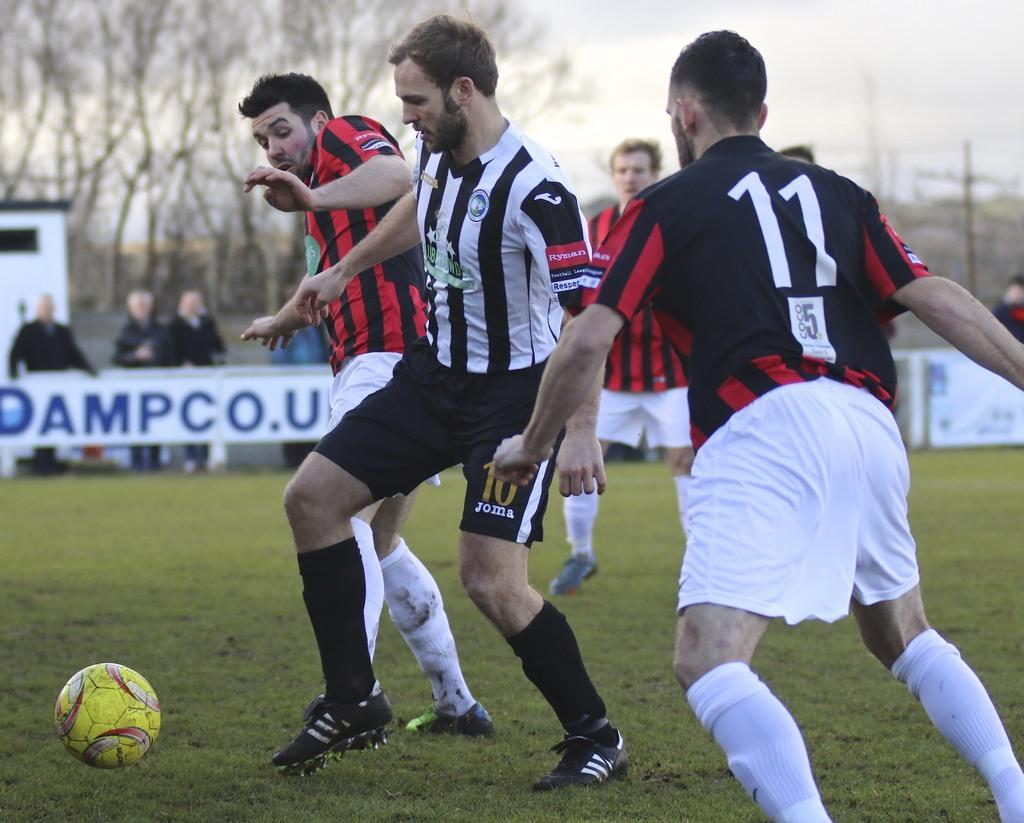<image>
Provide a brief description of the given image. Joma is found on one of the players althetic uniform's. 